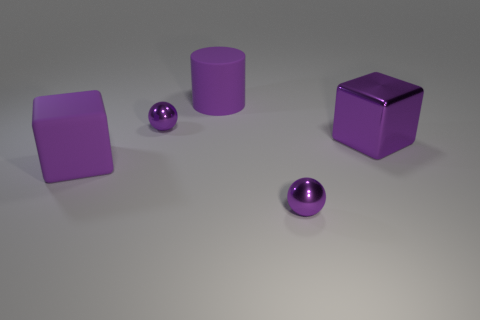There is a big cylinder that is the same color as the metal cube; what is it made of?
Your answer should be compact. Rubber. What number of other things are the same color as the matte cube?
Your response must be concise. 4. There is a large rubber object that is the same shape as the big metal object; what is its color?
Provide a short and direct response. Purple. What is the color of the large metal block?
Your answer should be compact. Purple. There is a tiny sphere that is in front of the object that is right of the purple metal object that is in front of the large metallic block; what is its color?
Provide a succinct answer. Purple. There is a large metal thing; is it the same shape as the tiny metallic thing that is in front of the purple rubber cube?
Your answer should be very brief. No. There is a big thing that is both in front of the large purple cylinder and on the left side of the large purple metal block; what is its color?
Your answer should be very brief. Purple. Are there any tiny purple things that have the same shape as the big purple metal thing?
Ensure brevity in your answer.  No. Do the rubber cylinder and the big shiny block have the same color?
Provide a short and direct response. Yes. Are there any purple things to the right of the large cube right of the big purple matte cube?
Your answer should be compact. No. 